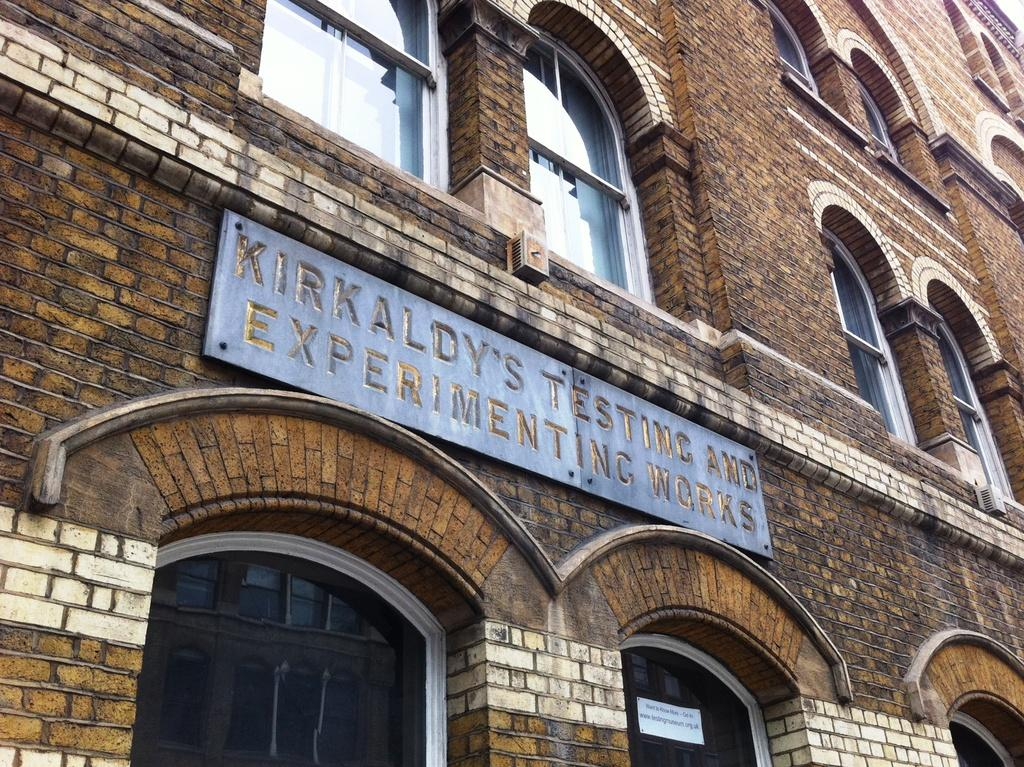What type of structures can be seen in the image? There are buildings in the image. What feature is common among the buildings? There are windows in the image. What additional element is present in the image? There is a banner in the image. Can you see any cobwebs hanging from the buildings in the image? There is no mention of cobwebs in the image, so we cannot determine if any are present. 